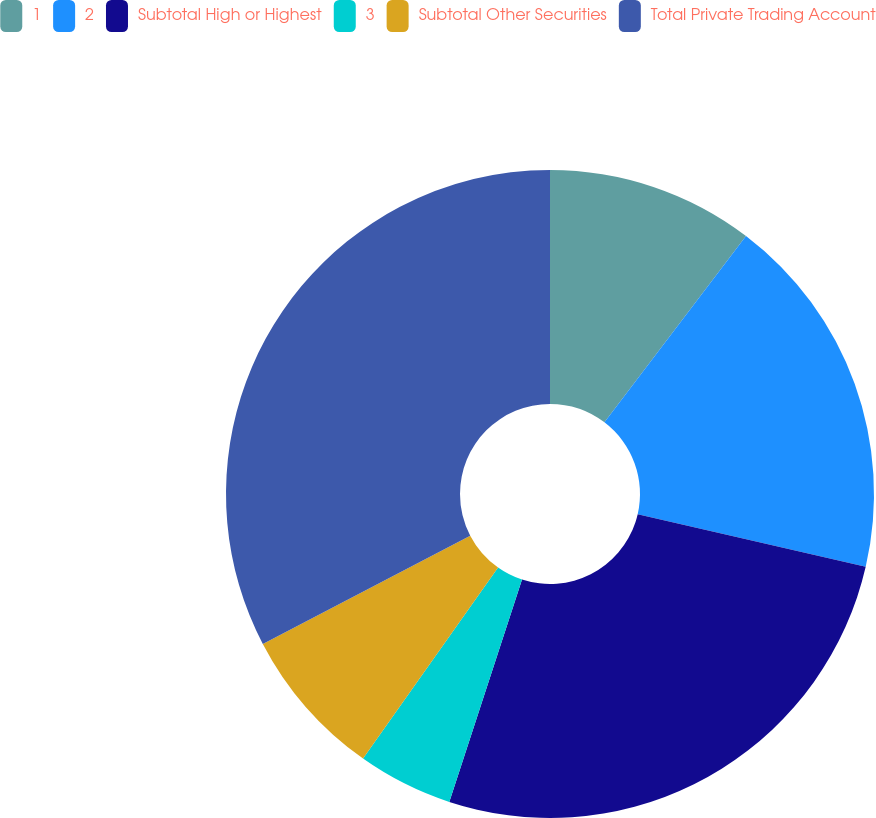Convert chart to OTSL. <chart><loc_0><loc_0><loc_500><loc_500><pie_chart><fcel>1<fcel>2<fcel>Subtotal High or Highest<fcel>3<fcel>Subtotal Other Securities<fcel>Total Private Trading Account<nl><fcel>10.34%<fcel>18.27%<fcel>26.42%<fcel>4.76%<fcel>7.55%<fcel>32.66%<nl></chart> 